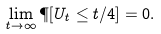Convert formula to latex. <formula><loc_0><loc_0><loc_500><loc_500>\lim _ { t \to \infty } \P [ U _ { t } \leq t / 4 ] = 0 .</formula> 